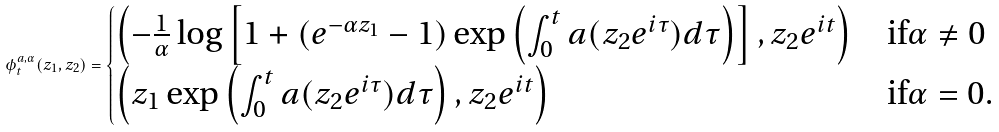<formula> <loc_0><loc_0><loc_500><loc_500>\phi ^ { a , \alpha } _ { t } ( z _ { 1 } , z _ { 2 } ) = \begin{cases} \left ( - \frac { 1 } { \alpha } \log \left [ 1 + ( e ^ { - \alpha z _ { 1 } } - 1 ) \exp \left ( \int _ { 0 } ^ { t } a ( z _ { 2 } e ^ { i \tau } ) d \tau \right ) \right ] , z _ { 2 } e ^ { i t } \right ) & \text {if} \alpha \ne 0 \\ \left ( z _ { 1 } \exp \left ( \int _ { 0 } ^ { t } a ( z _ { 2 } e ^ { i \tau } ) d \tau \right ) , z _ { 2 } e ^ { i t } \right ) & \text {if} \alpha = 0 . \end{cases}</formula> 